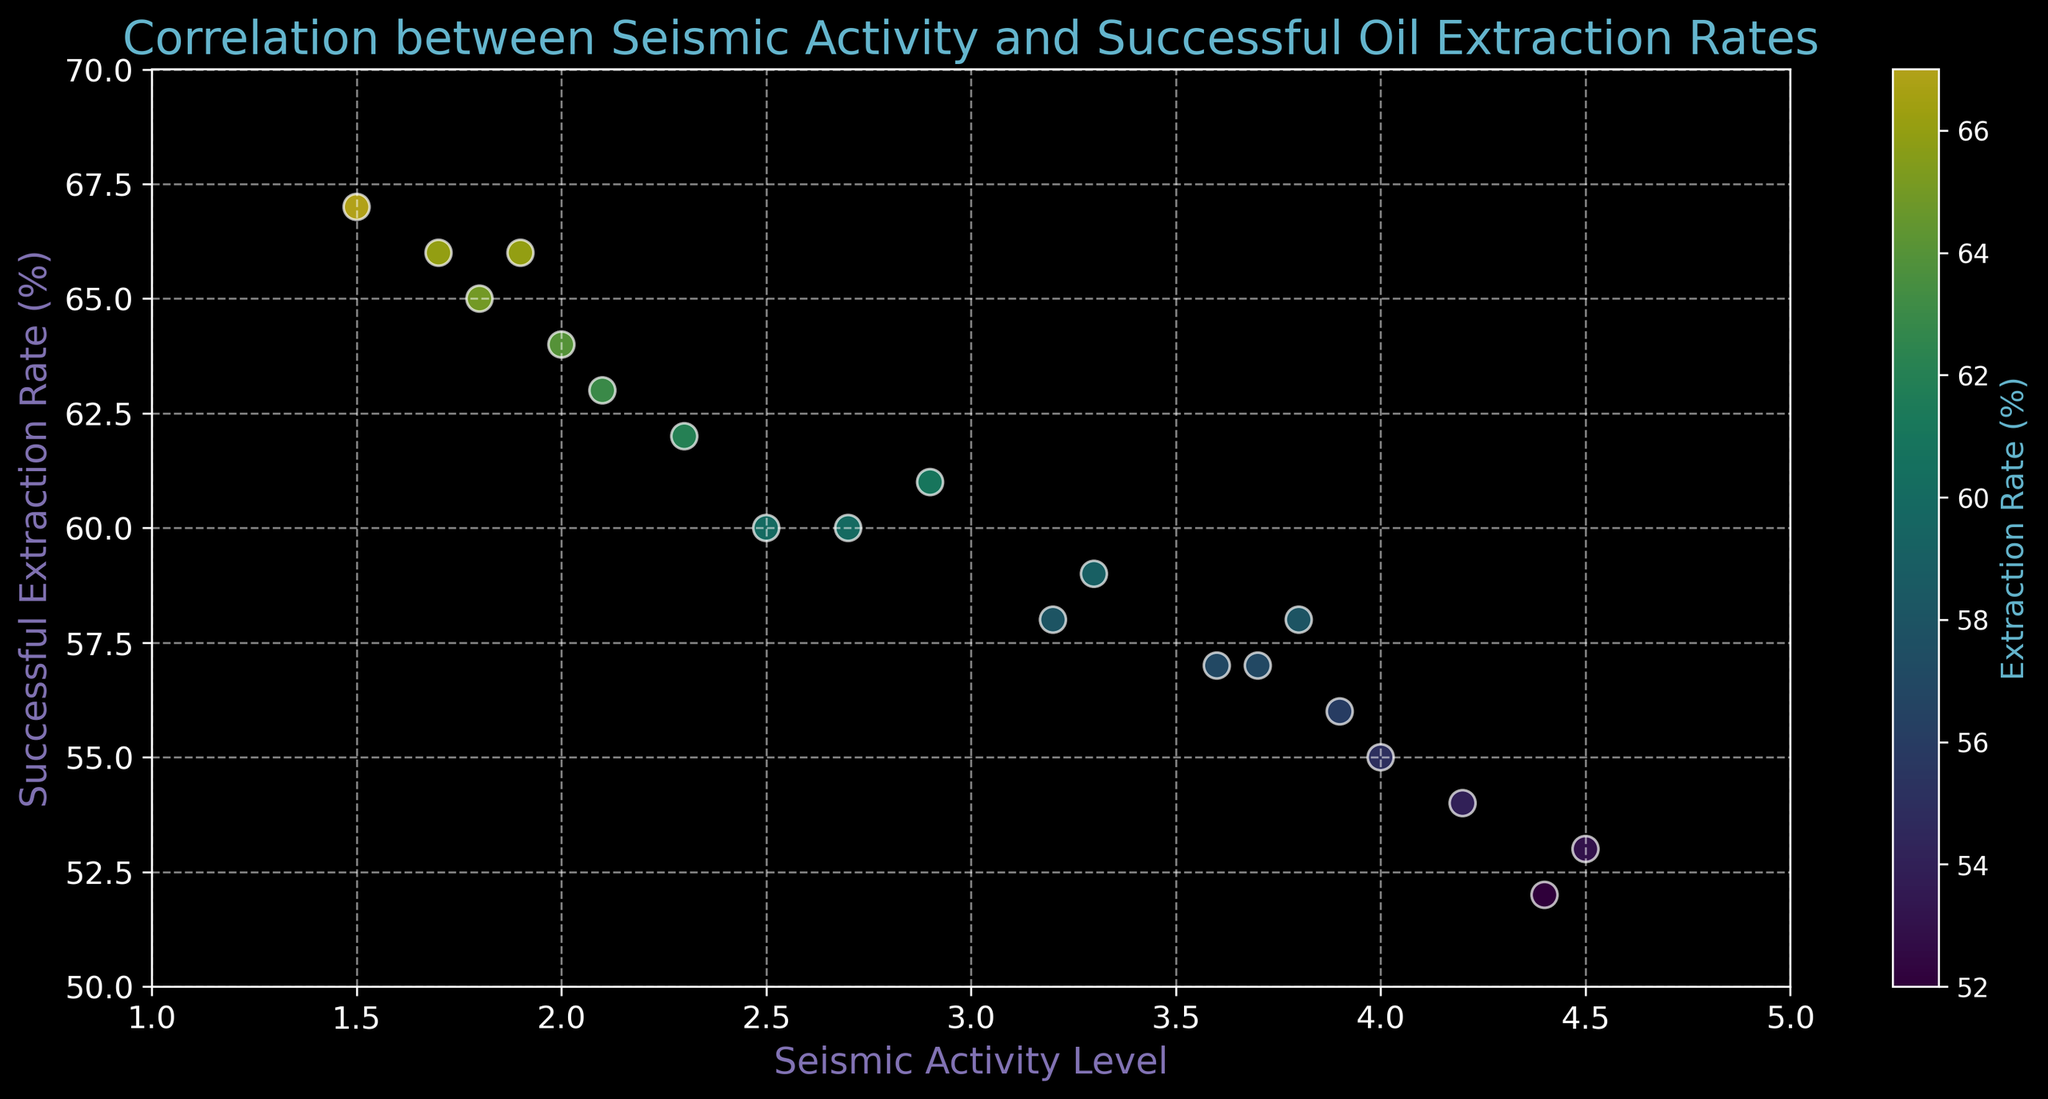What is the range of seismic activity levels presented in the scatter plot? To find the range, look at the minimum and maximum values of seismic activity on the x-axis. The plot shows a range of seismic activity levels from 1.5 to 4.5.
Answer: 1.5 to 4.5 Are higher seismic activity levels generally associated with higher or lower successful extraction rates? Observe the trend in the scatter plot. Higher seismic activity levels (right side of the x-axis) tend to have lower successful extraction rates (lower points on the y-axis).
Answer: Lower Which seismic activity level had the highest successful extraction rate? Identify the point with the highest y-value and note its x-value. The point at a seismic activity level of 1.5 has the highest successful extraction rate of 67%.
Answer: 1.5 What is the average successful extraction rate for seismic activity levels above 3.5? First, isolate the data points with seismic activity levels above 3.5. The points are: (3.7, 57), (4.0, 55), (4.2, 54), (4.4, 52), and (4.5, 53). Then calculate the mean: (57+55+54+52+53)/5 = 54.2.
Answer: 54.2 Which data point has the color that appears closest to the middle value on the color bar, and what is its seismic activity level and extraction rate? The middle value on the color bar is around 60%. Locate the data point closest to this color, which is (2.5, 60).
Answer: (2.5, 60) Are there more data points with successful extraction rates below 60% or above 60%? Count the number of points above and below the 60% y-axis line. Below 60%: 12 points; Above 60%: 8 points. There are more points below 60%.
Answer: Below 60% Is there a clear correlation between seismic activity level and successful extraction rate? Look at the overall distribution of points. There appears to be a slight negative correlation, as higher seismic activity levels seem to have lower extraction rates.
Answer: Yes, negative correlation What is the successful extraction rate for the seismic activity level of 2.7? Find the point on the plot where the seismic activity level is 2.7. The corresponding successful extraction rate is 60%.
Answer: 60% Which seismic activity level has the most similar successful extraction rates and what are the rates? Look for points that have very close y-values. Seismic activity levels 1.8 and 2.0 both have rates of 65% and 64%, respectively, which are quite close.
Answer: 1.8 (65%) and 2.0 (64%) 